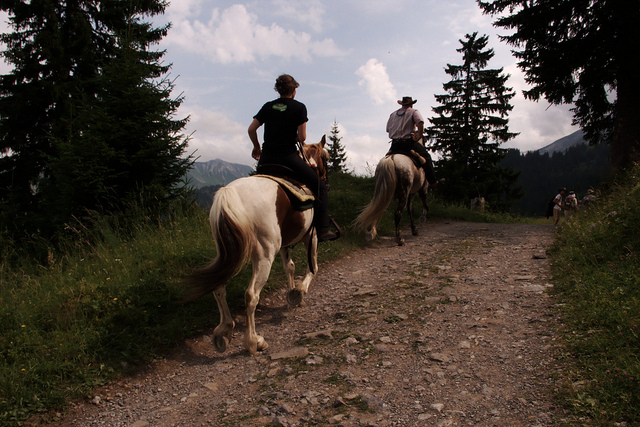<image>Which horse has more experience? It is ambiguous which horse has more experience. It can be either the front or the rear one. Which horse has more experience? I don't know which horse has more experience. It could be either the rear one or the lead one. 